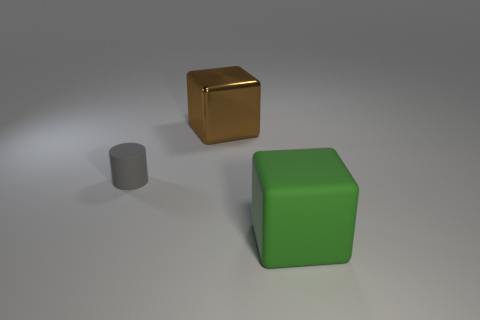Add 1 small green cylinders. How many objects exist? 4 Subtract all cylinders. How many objects are left? 2 Add 3 brown things. How many brown things are left? 4 Add 1 big matte cubes. How many big matte cubes exist? 2 Subtract 0 purple spheres. How many objects are left? 3 Subtract all gray things. Subtract all big rubber blocks. How many objects are left? 1 